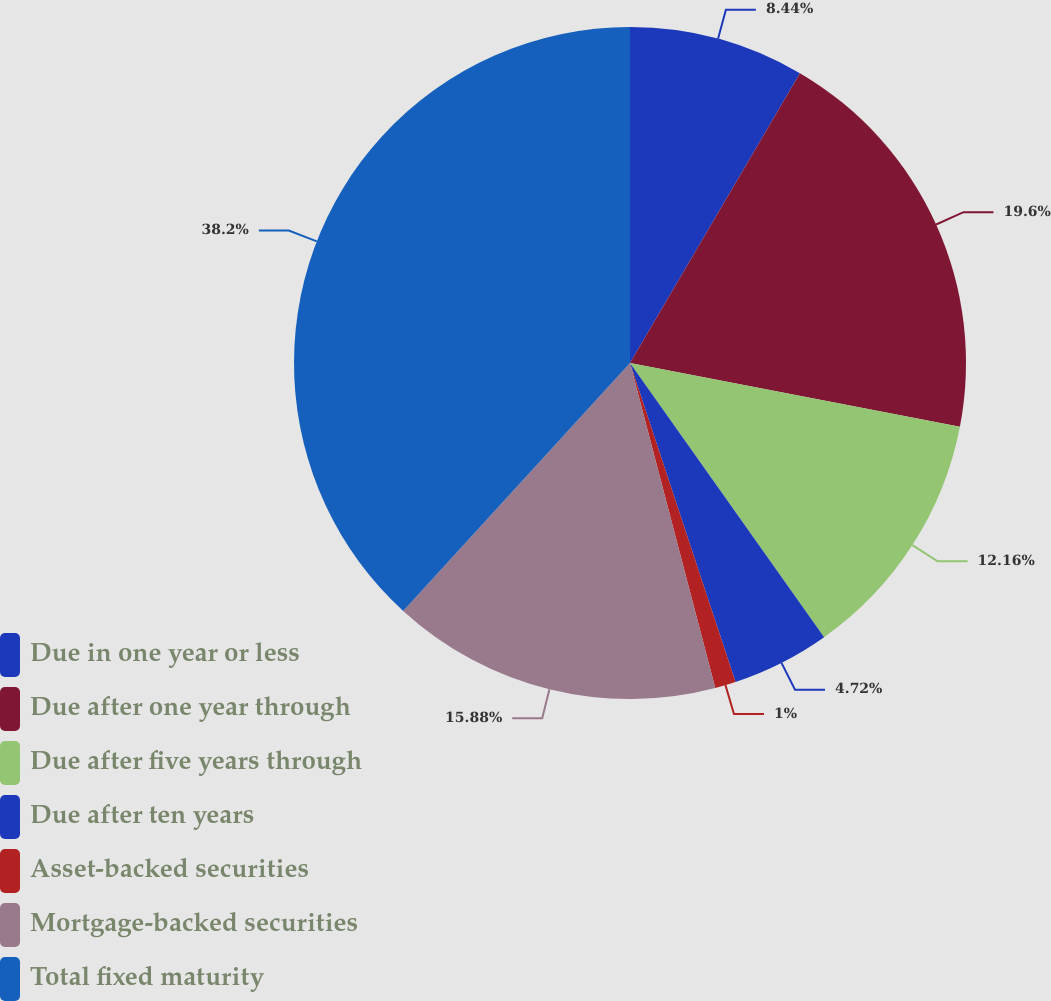Convert chart to OTSL. <chart><loc_0><loc_0><loc_500><loc_500><pie_chart><fcel>Due in one year or less<fcel>Due after one year through<fcel>Due after five years through<fcel>Due after ten years<fcel>Asset-backed securities<fcel>Mortgage-backed securities<fcel>Total fixed maturity<nl><fcel>8.44%<fcel>19.6%<fcel>12.16%<fcel>4.72%<fcel>1.0%<fcel>15.88%<fcel>38.21%<nl></chart> 